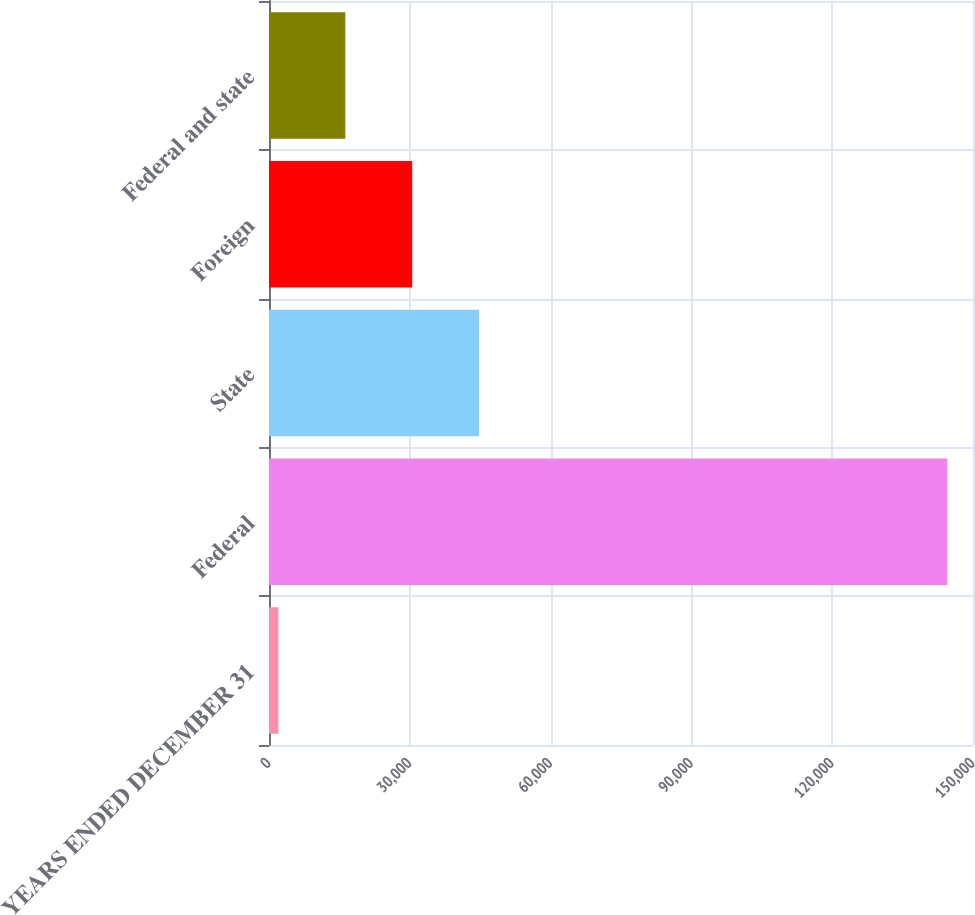Convert chart. <chart><loc_0><loc_0><loc_500><loc_500><bar_chart><fcel>YEARS ENDED DECEMBER 31<fcel>Federal<fcel>State<fcel>Foreign<fcel>Federal and state<nl><fcel>2007<fcel>144520<fcel>44760.9<fcel>30509.6<fcel>16258.3<nl></chart> 